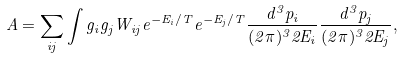Convert formula to latex. <formula><loc_0><loc_0><loc_500><loc_500>A = \sum _ { i j } \int g _ { i } g _ { j } W _ { i j } e ^ { - E _ { i } / T } e ^ { - E _ { j } / T } \frac { d ^ { 3 } p _ { i } } { ( 2 \pi ) ^ { 3 } 2 E _ { i } } \frac { d ^ { 3 } p _ { j } } { ( 2 \pi ) ^ { 3 } 2 E _ { j } } ,</formula> 